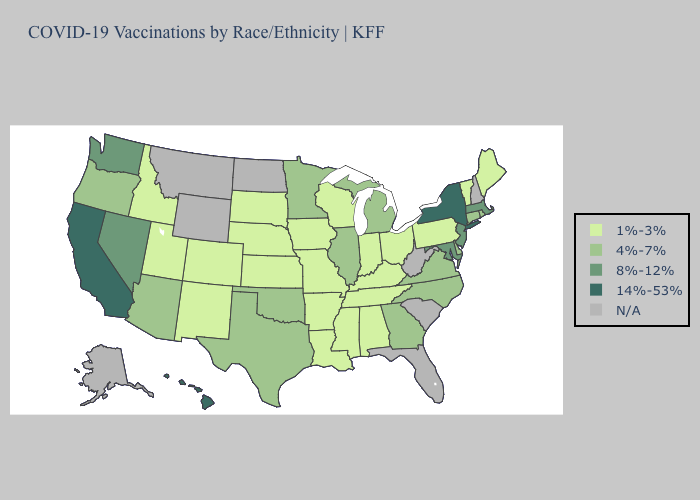Does Texas have the lowest value in the USA?
Keep it brief. No. Which states have the lowest value in the USA?
Concise answer only. Alabama, Arkansas, Colorado, Idaho, Indiana, Iowa, Kansas, Kentucky, Louisiana, Maine, Mississippi, Missouri, Nebraska, New Mexico, Ohio, Pennsylvania, South Dakota, Tennessee, Utah, Vermont, Wisconsin. Name the states that have a value in the range 14%-53%?
Concise answer only. California, Hawaii, New York. What is the lowest value in the South?
Answer briefly. 1%-3%. Name the states that have a value in the range N/A?
Quick response, please. Alaska, Florida, Montana, New Hampshire, North Dakota, South Carolina, West Virginia, Wyoming. Among the states that border Oregon , which have the highest value?
Be succinct. California. Does the first symbol in the legend represent the smallest category?
Give a very brief answer. Yes. What is the highest value in states that border Virginia?
Keep it brief. 8%-12%. How many symbols are there in the legend?
Give a very brief answer. 5. What is the lowest value in the USA?
Short answer required. 1%-3%. What is the value of Alaska?
Keep it brief. N/A. What is the value of North Carolina?
Be succinct. 4%-7%. Which states have the lowest value in the Northeast?
Concise answer only. Maine, Pennsylvania, Vermont. Among the states that border Ohio , does Michigan have the lowest value?
Write a very short answer. No. 